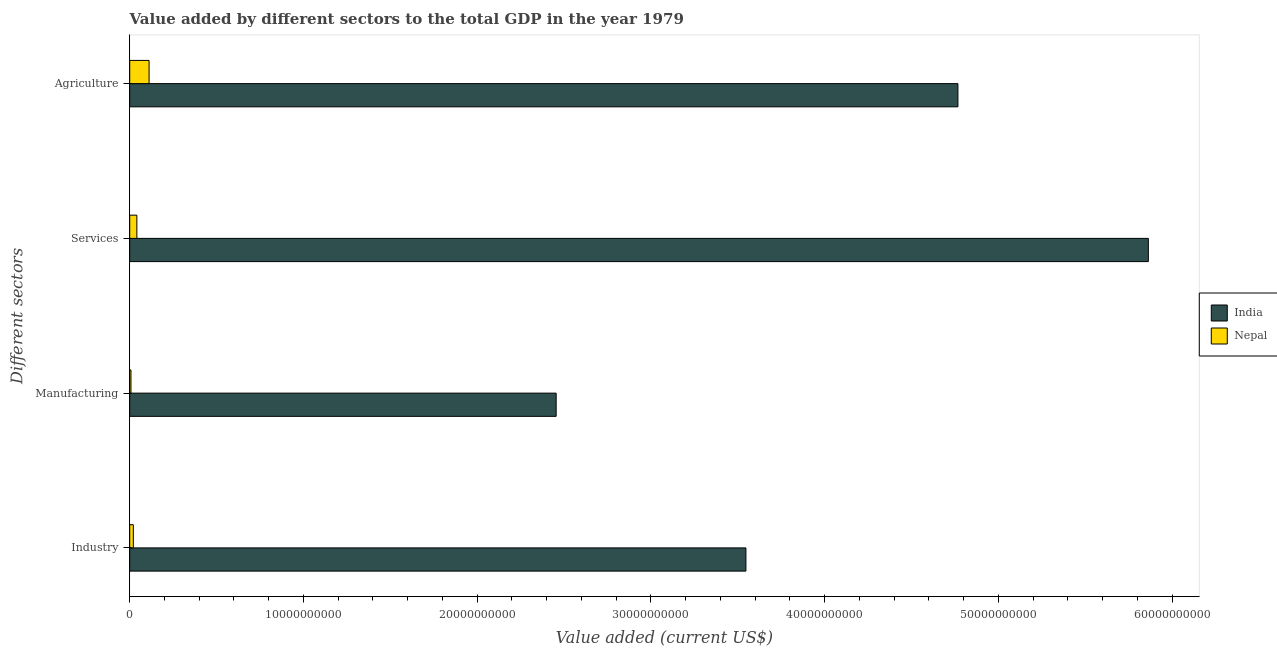How many groups of bars are there?
Offer a very short reply. 4. Are the number of bars on each tick of the Y-axis equal?
Ensure brevity in your answer.  Yes. How many bars are there on the 4th tick from the top?
Offer a very short reply. 2. How many bars are there on the 3rd tick from the bottom?
Provide a short and direct response. 2. What is the label of the 3rd group of bars from the top?
Give a very brief answer. Manufacturing. What is the value added by agricultural sector in India?
Your response must be concise. 4.77e+1. Across all countries, what is the maximum value added by agricultural sector?
Your response must be concise. 4.77e+1. Across all countries, what is the minimum value added by industrial sector?
Provide a succinct answer. 2.07e+08. In which country was the value added by agricultural sector maximum?
Your answer should be very brief. India. In which country was the value added by industrial sector minimum?
Offer a terse response. Nepal. What is the total value added by manufacturing sector in the graph?
Keep it short and to the point. 2.46e+1. What is the difference between the value added by services sector in Nepal and that in India?
Provide a succinct answer. -5.82e+1. What is the difference between the value added by agricultural sector in Nepal and the value added by manufacturing sector in India?
Provide a succinct answer. -2.34e+1. What is the average value added by agricultural sector per country?
Your response must be concise. 2.44e+1. What is the difference between the value added by industrial sector and value added by agricultural sector in India?
Give a very brief answer. -1.22e+1. In how many countries, is the value added by agricultural sector greater than 46000000000 US$?
Offer a very short reply. 1. What is the ratio of the value added by industrial sector in India to that in Nepal?
Offer a terse response. 171. Is the difference between the value added by services sector in Nepal and India greater than the difference between the value added by agricultural sector in Nepal and India?
Your answer should be very brief. No. What is the difference between the highest and the second highest value added by services sector?
Your answer should be very brief. 5.82e+1. What is the difference between the highest and the lowest value added by services sector?
Make the answer very short. 5.82e+1. In how many countries, is the value added by agricultural sector greater than the average value added by agricultural sector taken over all countries?
Make the answer very short. 1. Is the sum of the value added by industrial sector in India and Nepal greater than the maximum value added by agricultural sector across all countries?
Make the answer very short. No. What does the 2nd bar from the top in Services represents?
Offer a terse response. India. What does the 2nd bar from the bottom in Industry represents?
Offer a very short reply. Nepal. Does the graph contain any zero values?
Give a very brief answer. No. How are the legend labels stacked?
Give a very brief answer. Vertical. What is the title of the graph?
Give a very brief answer. Value added by different sectors to the total GDP in the year 1979. What is the label or title of the X-axis?
Give a very brief answer. Value added (current US$). What is the label or title of the Y-axis?
Give a very brief answer. Different sectors. What is the Value added (current US$) in India in Industry?
Your response must be concise. 3.55e+1. What is the Value added (current US$) of Nepal in Industry?
Your response must be concise. 2.07e+08. What is the Value added (current US$) of India in Manufacturing?
Your response must be concise. 2.45e+1. What is the Value added (current US$) in Nepal in Manufacturing?
Your answer should be very brief. 7.07e+07. What is the Value added (current US$) of India in Services?
Provide a short and direct response. 5.86e+1. What is the Value added (current US$) in Nepal in Services?
Give a very brief answer. 4.10e+08. What is the Value added (current US$) in India in Agriculture?
Keep it short and to the point. 4.77e+1. What is the Value added (current US$) in Nepal in Agriculture?
Offer a very short reply. 1.11e+09. Across all Different sectors, what is the maximum Value added (current US$) in India?
Keep it short and to the point. 5.86e+1. Across all Different sectors, what is the maximum Value added (current US$) of Nepal?
Provide a short and direct response. 1.11e+09. Across all Different sectors, what is the minimum Value added (current US$) in India?
Your answer should be compact. 2.45e+1. Across all Different sectors, what is the minimum Value added (current US$) in Nepal?
Provide a short and direct response. 7.07e+07. What is the total Value added (current US$) in India in the graph?
Offer a very short reply. 1.66e+11. What is the total Value added (current US$) of Nepal in the graph?
Ensure brevity in your answer.  1.80e+09. What is the difference between the Value added (current US$) in India in Industry and that in Manufacturing?
Make the answer very short. 1.09e+1. What is the difference between the Value added (current US$) in Nepal in Industry and that in Manufacturing?
Ensure brevity in your answer.  1.37e+08. What is the difference between the Value added (current US$) in India in Industry and that in Services?
Offer a terse response. -2.32e+1. What is the difference between the Value added (current US$) in Nepal in Industry and that in Services?
Give a very brief answer. -2.03e+08. What is the difference between the Value added (current US$) of India in Industry and that in Agriculture?
Provide a short and direct response. -1.22e+1. What is the difference between the Value added (current US$) of Nepal in Industry and that in Agriculture?
Give a very brief answer. -9.06e+08. What is the difference between the Value added (current US$) in India in Manufacturing and that in Services?
Offer a terse response. -3.41e+1. What is the difference between the Value added (current US$) in Nepal in Manufacturing and that in Services?
Offer a terse response. -3.40e+08. What is the difference between the Value added (current US$) in India in Manufacturing and that in Agriculture?
Make the answer very short. -2.31e+1. What is the difference between the Value added (current US$) in Nepal in Manufacturing and that in Agriculture?
Keep it short and to the point. -1.04e+09. What is the difference between the Value added (current US$) of India in Services and that in Agriculture?
Provide a succinct answer. 1.10e+1. What is the difference between the Value added (current US$) of Nepal in Services and that in Agriculture?
Offer a very short reply. -7.03e+08. What is the difference between the Value added (current US$) of India in Industry and the Value added (current US$) of Nepal in Manufacturing?
Keep it short and to the point. 3.54e+1. What is the difference between the Value added (current US$) of India in Industry and the Value added (current US$) of Nepal in Services?
Keep it short and to the point. 3.51e+1. What is the difference between the Value added (current US$) in India in Industry and the Value added (current US$) in Nepal in Agriculture?
Make the answer very short. 3.44e+1. What is the difference between the Value added (current US$) of India in Manufacturing and the Value added (current US$) of Nepal in Services?
Give a very brief answer. 2.41e+1. What is the difference between the Value added (current US$) in India in Manufacturing and the Value added (current US$) in Nepal in Agriculture?
Ensure brevity in your answer.  2.34e+1. What is the difference between the Value added (current US$) of India in Services and the Value added (current US$) of Nepal in Agriculture?
Ensure brevity in your answer.  5.75e+1. What is the average Value added (current US$) in India per Different sectors?
Your response must be concise. 4.16e+1. What is the average Value added (current US$) of Nepal per Different sectors?
Provide a short and direct response. 4.51e+08. What is the difference between the Value added (current US$) of India and Value added (current US$) of Nepal in Industry?
Keep it short and to the point. 3.53e+1. What is the difference between the Value added (current US$) of India and Value added (current US$) of Nepal in Manufacturing?
Your response must be concise. 2.45e+1. What is the difference between the Value added (current US$) in India and Value added (current US$) in Nepal in Services?
Your answer should be compact. 5.82e+1. What is the difference between the Value added (current US$) in India and Value added (current US$) in Nepal in Agriculture?
Your answer should be very brief. 4.66e+1. What is the ratio of the Value added (current US$) of India in Industry to that in Manufacturing?
Offer a terse response. 1.45. What is the ratio of the Value added (current US$) of Nepal in Industry to that in Manufacturing?
Your answer should be compact. 2.94. What is the ratio of the Value added (current US$) of India in Industry to that in Services?
Provide a short and direct response. 0.6. What is the ratio of the Value added (current US$) of Nepal in Industry to that in Services?
Your answer should be compact. 0.51. What is the ratio of the Value added (current US$) of India in Industry to that in Agriculture?
Give a very brief answer. 0.74. What is the ratio of the Value added (current US$) in Nepal in Industry to that in Agriculture?
Offer a very short reply. 0.19. What is the ratio of the Value added (current US$) of India in Manufacturing to that in Services?
Provide a short and direct response. 0.42. What is the ratio of the Value added (current US$) of Nepal in Manufacturing to that in Services?
Make the answer very short. 0.17. What is the ratio of the Value added (current US$) in India in Manufacturing to that in Agriculture?
Your answer should be compact. 0.51. What is the ratio of the Value added (current US$) in Nepal in Manufacturing to that in Agriculture?
Make the answer very short. 0.06. What is the ratio of the Value added (current US$) in India in Services to that in Agriculture?
Make the answer very short. 1.23. What is the ratio of the Value added (current US$) in Nepal in Services to that in Agriculture?
Make the answer very short. 0.37. What is the difference between the highest and the second highest Value added (current US$) in India?
Keep it short and to the point. 1.10e+1. What is the difference between the highest and the second highest Value added (current US$) of Nepal?
Your response must be concise. 7.03e+08. What is the difference between the highest and the lowest Value added (current US$) of India?
Your answer should be compact. 3.41e+1. What is the difference between the highest and the lowest Value added (current US$) in Nepal?
Provide a short and direct response. 1.04e+09. 